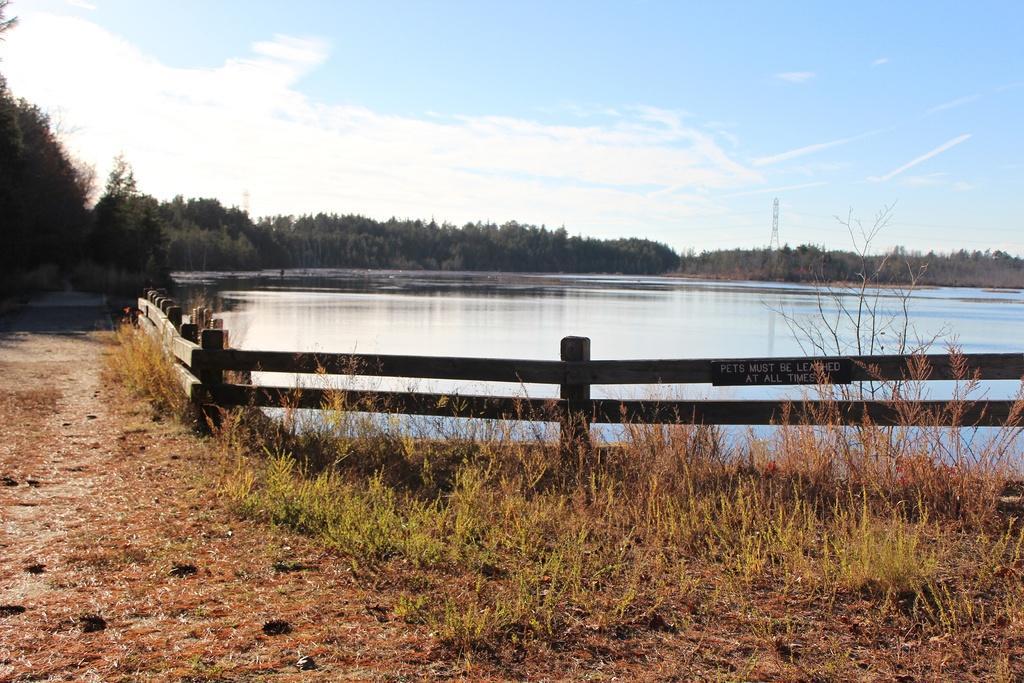Please provide a concise description of this image. In the center of the image, we can see a lake and in the background, there is a fence and we can see a board and there are trees. At the bottom, there is ground and some part of it is covered with plants. At the top, there is sky. 